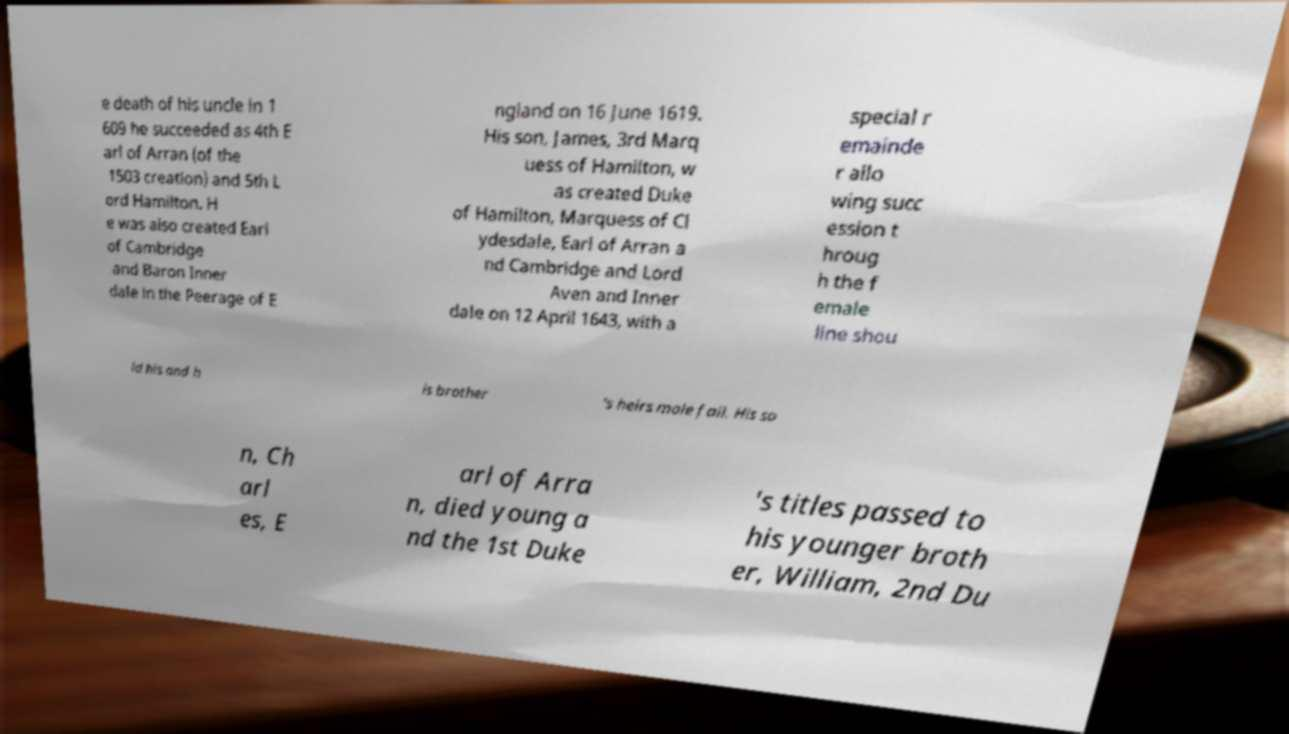Please identify and transcribe the text found in this image. e death of his uncle in 1 609 he succeeded as 4th E arl of Arran (of the 1503 creation) and 5th L ord Hamilton. H e was also created Earl of Cambridge and Baron Inner dale in the Peerage of E ngland on 16 June 1619. His son, James, 3rd Marq uess of Hamilton, w as created Duke of Hamilton, Marquess of Cl ydesdale, Earl of Arran a nd Cambridge and Lord Aven and Inner dale on 12 April 1643, with a special r emainde r allo wing succ ession t hroug h the f emale line shou ld his and h is brother 's heirs male fail. His so n, Ch arl es, E arl of Arra n, died young a nd the 1st Duke 's titles passed to his younger broth er, William, 2nd Du 